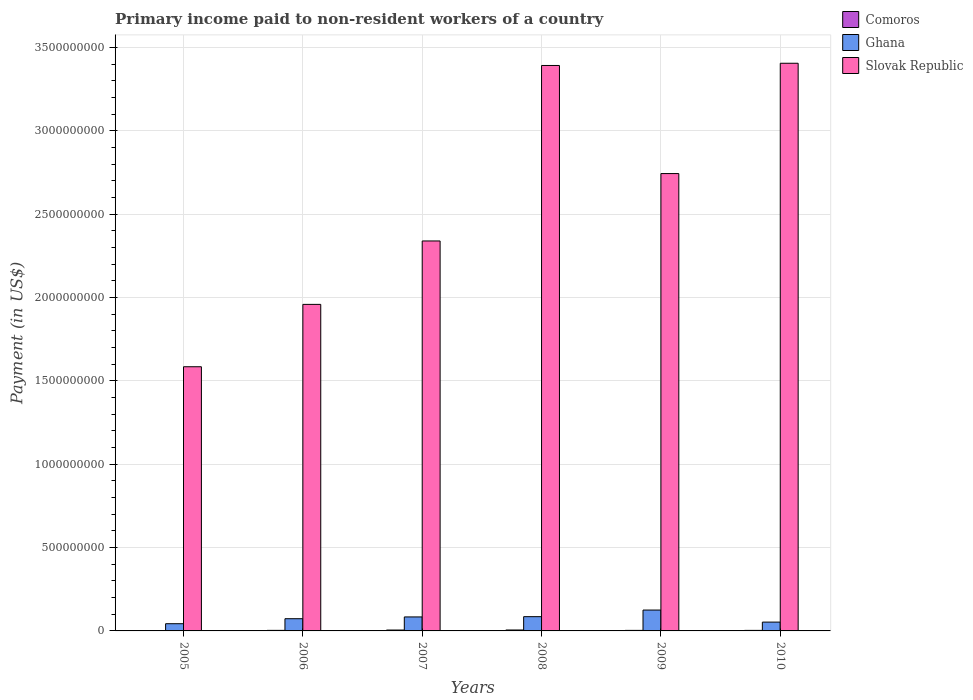How many groups of bars are there?
Offer a terse response. 6. How many bars are there on the 2nd tick from the left?
Keep it short and to the point. 3. In how many cases, is the number of bars for a given year not equal to the number of legend labels?
Provide a succinct answer. 0. What is the amount paid to workers in Slovak Republic in 2008?
Offer a very short reply. 3.39e+09. Across all years, what is the maximum amount paid to workers in Slovak Republic?
Give a very brief answer. 3.41e+09. Across all years, what is the minimum amount paid to workers in Slovak Republic?
Offer a terse response. 1.58e+09. In which year was the amount paid to workers in Ghana maximum?
Your response must be concise. 2009. In which year was the amount paid to workers in Slovak Republic minimum?
Ensure brevity in your answer.  2005. What is the total amount paid to workers in Ghana in the graph?
Keep it short and to the point. 4.64e+08. What is the difference between the amount paid to workers in Ghana in 2005 and that in 2009?
Ensure brevity in your answer.  -8.19e+07. What is the difference between the amount paid to workers in Comoros in 2010 and the amount paid to workers in Ghana in 2006?
Ensure brevity in your answer.  -7.00e+07. What is the average amount paid to workers in Ghana per year?
Ensure brevity in your answer.  7.74e+07. In the year 2009, what is the difference between the amount paid to workers in Slovak Republic and amount paid to workers in Comoros?
Offer a terse response. 2.74e+09. In how many years, is the amount paid to workers in Comoros greater than 1800000000 US$?
Give a very brief answer. 0. What is the ratio of the amount paid to workers in Ghana in 2005 to that in 2008?
Provide a short and direct response. 0.51. Is the amount paid to workers in Slovak Republic in 2005 less than that in 2010?
Make the answer very short. Yes. Is the difference between the amount paid to workers in Slovak Republic in 2008 and 2009 greater than the difference between the amount paid to workers in Comoros in 2008 and 2009?
Your response must be concise. Yes. What is the difference between the highest and the second highest amount paid to workers in Slovak Republic?
Offer a terse response. 1.33e+07. What is the difference between the highest and the lowest amount paid to workers in Slovak Republic?
Give a very brief answer. 1.82e+09. Is the sum of the amount paid to workers in Ghana in 2008 and 2009 greater than the maximum amount paid to workers in Slovak Republic across all years?
Your answer should be very brief. No. What does the 3rd bar from the right in 2005 represents?
Ensure brevity in your answer.  Comoros. Is it the case that in every year, the sum of the amount paid to workers in Comoros and amount paid to workers in Ghana is greater than the amount paid to workers in Slovak Republic?
Your answer should be compact. No. How many bars are there?
Offer a terse response. 18. Does the graph contain any zero values?
Ensure brevity in your answer.  No. Does the graph contain grids?
Your answer should be very brief. Yes. What is the title of the graph?
Ensure brevity in your answer.  Primary income paid to non-resident workers of a country. What is the label or title of the X-axis?
Ensure brevity in your answer.  Years. What is the label or title of the Y-axis?
Your response must be concise. Payment (in US$). What is the Payment (in US$) in Comoros in 2005?
Provide a succinct answer. 2.44e+06. What is the Payment (in US$) of Ghana in 2005?
Provide a short and direct response. 4.33e+07. What is the Payment (in US$) in Slovak Republic in 2005?
Your answer should be very brief. 1.58e+09. What is the Payment (in US$) in Comoros in 2006?
Ensure brevity in your answer.  3.37e+06. What is the Payment (in US$) of Ghana in 2006?
Your response must be concise. 7.33e+07. What is the Payment (in US$) of Slovak Republic in 2006?
Give a very brief answer. 1.96e+09. What is the Payment (in US$) of Comoros in 2007?
Provide a succinct answer. 5.32e+06. What is the Payment (in US$) in Ghana in 2007?
Make the answer very short. 8.40e+07. What is the Payment (in US$) in Slovak Republic in 2007?
Offer a terse response. 2.34e+09. What is the Payment (in US$) in Comoros in 2008?
Ensure brevity in your answer.  5.55e+06. What is the Payment (in US$) of Ghana in 2008?
Give a very brief answer. 8.56e+07. What is the Payment (in US$) in Slovak Republic in 2008?
Give a very brief answer. 3.39e+09. What is the Payment (in US$) in Comoros in 2009?
Your answer should be very brief. 3.19e+06. What is the Payment (in US$) of Ghana in 2009?
Make the answer very short. 1.25e+08. What is the Payment (in US$) in Slovak Republic in 2009?
Ensure brevity in your answer.  2.74e+09. What is the Payment (in US$) in Comoros in 2010?
Provide a succinct answer. 3.23e+06. What is the Payment (in US$) of Ghana in 2010?
Your answer should be compact. 5.29e+07. What is the Payment (in US$) of Slovak Republic in 2010?
Your answer should be very brief. 3.41e+09. Across all years, what is the maximum Payment (in US$) in Comoros?
Your answer should be compact. 5.55e+06. Across all years, what is the maximum Payment (in US$) in Ghana?
Ensure brevity in your answer.  1.25e+08. Across all years, what is the maximum Payment (in US$) of Slovak Republic?
Provide a succinct answer. 3.41e+09. Across all years, what is the minimum Payment (in US$) of Comoros?
Your response must be concise. 2.44e+06. Across all years, what is the minimum Payment (in US$) in Ghana?
Make the answer very short. 4.33e+07. Across all years, what is the minimum Payment (in US$) in Slovak Republic?
Offer a terse response. 1.58e+09. What is the total Payment (in US$) of Comoros in the graph?
Your answer should be compact. 2.31e+07. What is the total Payment (in US$) of Ghana in the graph?
Offer a terse response. 4.64e+08. What is the total Payment (in US$) in Slovak Republic in the graph?
Provide a succinct answer. 1.54e+1. What is the difference between the Payment (in US$) of Comoros in 2005 and that in 2006?
Your answer should be compact. -9.27e+05. What is the difference between the Payment (in US$) in Ghana in 2005 and that in 2006?
Make the answer very short. -3.00e+07. What is the difference between the Payment (in US$) of Slovak Republic in 2005 and that in 2006?
Ensure brevity in your answer.  -3.74e+08. What is the difference between the Payment (in US$) in Comoros in 2005 and that in 2007?
Your answer should be very brief. -2.87e+06. What is the difference between the Payment (in US$) in Ghana in 2005 and that in 2007?
Ensure brevity in your answer.  -4.07e+07. What is the difference between the Payment (in US$) of Slovak Republic in 2005 and that in 2007?
Your answer should be compact. -7.55e+08. What is the difference between the Payment (in US$) in Comoros in 2005 and that in 2008?
Keep it short and to the point. -3.11e+06. What is the difference between the Payment (in US$) of Ghana in 2005 and that in 2008?
Provide a succinct answer. -4.23e+07. What is the difference between the Payment (in US$) of Slovak Republic in 2005 and that in 2008?
Offer a very short reply. -1.81e+09. What is the difference between the Payment (in US$) in Comoros in 2005 and that in 2009?
Keep it short and to the point. -7.48e+05. What is the difference between the Payment (in US$) of Ghana in 2005 and that in 2009?
Make the answer very short. -8.19e+07. What is the difference between the Payment (in US$) of Slovak Republic in 2005 and that in 2009?
Offer a very short reply. -1.16e+09. What is the difference between the Payment (in US$) in Comoros in 2005 and that in 2010?
Provide a short and direct response. -7.91e+05. What is the difference between the Payment (in US$) in Ghana in 2005 and that in 2010?
Offer a very short reply. -9.65e+06. What is the difference between the Payment (in US$) in Slovak Republic in 2005 and that in 2010?
Ensure brevity in your answer.  -1.82e+09. What is the difference between the Payment (in US$) of Comoros in 2006 and that in 2007?
Keep it short and to the point. -1.95e+06. What is the difference between the Payment (in US$) in Ghana in 2006 and that in 2007?
Ensure brevity in your answer.  -1.07e+07. What is the difference between the Payment (in US$) of Slovak Republic in 2006 and that in 2007?
Offer a terse response. -3.81e+08. What is the difference between the Payment (in US$) in Comoros in 2006 and that in 2008?
Give a very brief answer. -2.18e+06. What is the difference between the Payment (in US$) in Ghana in 2006 and that in 2008?
Give a very brief answer. -1.23e+07. What is the difference between the Payment (in US$) of Slovak Republic in 2006 and that in 2008?
Keep it short and to the point. -1.43e+09. What is the difference between the Payment (in US$) of Comoros in 2006 and that in 2009?
Provide a short and direct response. 1.78e+05. What is the difference between the Payment (in US$) in Ghana in 2006 and that in 2009?
Keep it short and to the point. -5.19e+07. What is the difference between the Payment (in US$) of Slovak Republic in 2006 and that in 2009?
Keep it short and to the point. -7.85e+08. What is the difference between the Payment (in US$) in Comoros in 2006 and that in 2010?
Offer a terse response. 1.35e+05. What is the difference between the Payment (in US$) of Ghana in 2006 and that in 2010?
Offer a very short reply. 2.03e+07. What is the difference between the Payment (in US$) of Slovak Republic in 2006 and that in 2010?
Provide a succinct answer. -1.45e+09. What is the difference between the Payment (in US$) in Comoros in 2007 and that in 2008?
Offer a terse response. -2.30e+05. What is the difference between the Payment (in US$) in Ghana in 2007 and that in 2008?
Your response must be concise. -1.58e+06. What is the difference between the Payment (in US$) in Slovak Republic in 2007 and that in 2008?
Keep it short and to the point. -1.05e+09. What is the difference between the Payment (in US$) in Comoros in 2007 and that in 2009?
Offer a very short reply. 2.13e+06. What is the difference between the Payment (in US$) in Ghana in 2007 and that in 2009?
Ensure brevity in your answer.  -4.12e+07. What is the difference between the Payment (in US$) in Slovak Republic in 2007 and that in 2009?
Keep it short and to the point. -4.04e+08. What is the difference between the Payment (in US$) of Comoros in 2007 and that in 2010?
Offer a very short reply. 2.08e+06. What is the difference between the Payment (in US$) in Ghana in 2007 and that in 2010?
Provide a succinct answer. 3.11e+07. What is the difference between the Payment (in US$) in Slovak Republic in 2007 and that in 2010?
Your response must be concise. -1.07e+09. What is the difference between the Payment (in US$) in Comoros in 2008 and that in 2009?
Keep it short and to the point. 2.36e+06. What is the difference between the Payment (in US$) in Ghana in 2008 and that in 2009?
Offer a very short reply. -3.96e+07. What is the difference between the Payment (in US$) of Slovak Republic in 2008 and that in 2009?
Your response must be concise. 6.49e+08. What is the difference between the Payment (in US$) in Comoros in 2008 and that in 2010?
Your response must be concise. 2.31e+06. What is the difference between the Payment (in US$) in Ghana in 2008 and that in 2010?
Give a very brief answer. 3.26e+07. What is the difference between the Payment (in US$) of Slovak Republic in 2008 and that in 2010?
Provide a succinct answer. -1.33e+07. What is the difference between the Payment (in US$) of Comoros in 2009 and that in 2010?
Offer a terse response. -4.30e+04. What is the difference between the Payment (in US$) in Ghana in 2009 and that in 2010?
Provide a short and direct response. 7.23e+07. What is the difference between the Payment (in US$) of Slovak Republic in 2009 and that in 2010?
Offer a terse response. -6.62e+08. What is the difference between the Payment (in US$) in Comoros in 2005 and the Payment (in US$) in Ghana in 2006?
Your answer should be compact. -7.08e+07. What is the difference between the Payment (in US$) in Comoros in 2005 and the Payment (in US$) in Slovak Republic in 2006?
Give a very brief answer. -1.96e+09. What is the difference between the Payment (in US$) in Ghana in 2005 and the Payment (in US$) in Slovak Republic in 2006?
Make the answer very short. -1.92e+09. What is the difference between the Payment (in US$) in Comoros in 2005 and the Payment (in US$) in Ghana in 2007?
Give a very brief answer. -8.15e+07. What is the difference between the Payment (in US$) in Comoros in 2005 and the Payment (in US$) in Slovak Republic in 2007?
Ensure brevity in your answer.  -2.34e+09. What is the difference between the Payment (in US$) in Ghana in 2005 and the Payment (in US$) in Slovak Republic in 2007?
Your answer should be very brief. -2.30e+09. What is the difference between the Payment (in US$) in Comoros in 2005 and the Payment (in US$) in Ghana in 2008?
Your response must be concise. -8.31e+07. What is the difference between the Payment (in US$) of Comoros in 2005 and the Payment (in US$) of Slovak Republic in 2008?
Give a very brief answer. -3.39e+09. What is the difference between the Payment (in US$) of Ghana in 2005 and the Payment (in US$) of Slovak Republic in 2008?
Provide a succinct answer. -3.35e+09. What is the difference between the Payment (in US$) in Comoros in 2005 and the Payment (in US$) in Ghana in 2009?
Make the answer very short. -1.23e+08. What is the difference between the Payment (in US$) of Comoros in 2005 and the Payment (in US$) of Slovak Republic in 2009?
Make the answer very short. -2.74e+09. What is the difference between the Payment (in US$) of Ghana in 2005 and the Payment (in US$) of Slovak Republic in 2009?
Make the answer very short. -2.70e+09. What is the difference between the Payment (in US$) in Comoros in 2005 and the Payment (in US$) in Ghana in 2010?
Your response must be concise. -5.05e+07. What is the difference between the Payment (in US$) in Comoros in 2005 and the Payment (in US$) in Slovak Republic in 2010?
Make the answer very short. -3.40e+09. What is the difference between the Payment (in US$) of Ghana in 2005 and the Payment (in US$) of Slovak Republic in 2010?
Make the answer very short. -3.36e+09. What is the difference between the Payment (in US$) in Comoros in 2006 and the Payment (in US$) in Ghana in 2007?
Give a very brief answer. -8.06e+07. What is the difference between the Payment (in US$) of Comoros in 2006 and the Payment (in US$) of Slovak Republic in 2007?
Offer a terse response. -2.34e+09. What is the difference between the Payment (in US$) of Ghana in 2006 and the Payment (in US$) of Slovak Republic in 2007?
Your answer should be compact. -2.27e+09. What is the difference between the Payment (in US$) of Comoros in 2006 and the Payment (in US$) of Ghana in 2008?
Offer a terse response. -8.22e+07. What is the difference between the Payment (in US$) in Comoros in 2006 and the Payment (in US$) in Slovak Republic in 2008?
Offer a very short reply. -3.39e+09. What is the difference between the Payment (in US$) of Ghana in 2006 and the Payment (in US$) of Slovak Republic in 2008?
Offer a terse response. -3.32e+09. What is the difference between the Payment (in US$) of Comoros in 2006 and the Payment (in US$) of Ghana in 2009?
Provide a succinct answer. -1.22e+08. What is the difference between the Payment (in US$) in Comoros in 2006 and the Payment (in US$) in Slovak Republic in 2009?
Provide a succinct answer. -2.74e+09. What is the difference between the Payment (in US$) in Ghana in 2006 and the Payment (in US$) in Slovak Republic in 2009?
Your response must be concise. -2.67e+09. What is the difference between the Payment (in US$) in Comoros in 2006 and the Payment (in US$) in Ghana in 2010?
Your answer should be compact. -4.96e+07. What is the difference between the Payment (in US$) of Comoros in 2006 and the Payment (in US$) of Slovak Republic in 2010?
Give a very brief answer. -3.40e+09. What is the difference between the Payment (in US$) of Ghana in 2006 and the Payment (in US$) of Slovak Republic in 2010?
Your answer should be compact. -3.33e+09. What is the difference between the Payment (in US$) in Comoros in 2007 and the Payment (in US$) in Ghana in 2008?
Your response must be concise. -8.02e+07. What is the difference between the Payment (in US$) in Comoros in 2007 and the Payment (in US$) in Slovak Republic in 2008?
Make the answer very short. -3.39e+09. What is the difference between the Payment (in US$) of Ghana in 2007 and the Payment (in US$) of Slovak Republic in 2008?
Make the answer very short. -3.31e+09. What is the difference between the Payment (in US$) of Comoros in 2007 and the Payment (in US$) of Ghana in 2009?
Provide a succinct answer. -1.20e+08. What is the difference between the Payment (in US$) of Comoros in 2007 and the Payment (in US$) of Slovak Republic in 2009?
Your answer should be very brief. -2.74e+09. What is the difference between the Payment (in US$) in Ghana in 2007 and the Payment (in US$) in Slovak Republic in 2009?
Provide a short and direct response. -2.66e+09. What is the difference between the Payment (in US$) of Comoros in 2007 and the Payment (in US$) of Ghana in 2010?
Your answer should be very brief. -4.76e+07. What is the difference between the Payment (in US$) of Comoros in 2007 and the Payment (in US$) of Slovak Republic in 2010?
Provide a short and direct response. -3.40e+09. What is the difference between the Payment (in US$) of Ghana in 2007 and the Payment (in US$) of Slovak Republic in 2010?
Your answer should be very brief. -3.32e+09. What is the difference between the Payment (in US$) of Comoros in 2008 and the Payment (in US$) of Ghana in 2009?
Give a very brief answer. -1.20e+08. What is the difference between the Payment (in US$) in Comoros in 2008 and the Payment (in US$) in Slovak Republic in 2009?
Your answer should be very brief. -2.74e+09. What is the difference between the Payment (in US$) of Ghana in 2008 and the Payment (in US$) of Slovak Republic in 2009?
Your answer should be very brief. -2.66e+09. What is the difference between the Payment (in US$) in Comoros in 2008 and the Payment (in US$) in Ghana in 2010?
Ensure brevity in your answer.  -4.74e+07. What is the difference between the Payment (in US$) of Comoros in 2008 and the Payment (in US$) of Slovak Republic in 2010?
Offer a very short reply. -3.40e+09. What is the difference between the Payment (in US$) of Ghana in 2008 and the Payment (in US$) of Slovak Republic in 2010?
Provide a succinct answer. -3.32e+09. What is the difference between the Payment (in US$) in Comoros in 2009 and the Payment (in US$) in Ghana in 2010?
Your response must be concise. -4.97e+07. What is the difference between the Payment (in US$) of Comoros in 2009 and the Payment (in US$) of Slovak Republic in 2010?
Provide a short and direct response. -3.40e+09. What is the difference between the Payment (in US$) of Ghana in 2009 and the Payment (in US$) of Slovak Republic in 2010?
Give a very brief answer. -3.28e+09. What is the average Payment (in US$) of Comoros per year?
Provide a succinct answer. 3.85e+06. What is the average Payment (in US$) of Ghana per year?
Offer a terse response. 7.74e+07. What is the average Payment (in US$) in Slovak Republic per year?
Your answer should be very brief. 2.57e+09. In the year 2005, what is the difference between the Payment (in US$) of Comoros and Payment (in US$) of Ghana?
Give a very brief answer. -4.08e+07. In the year 2005, what is the difference between the Payment (in US$) in Comoros and Payment (in US$) in Slovak Republic?
Provide a succinct answer. -1.58e+09. In the year 2005, what is the difference between the Payment (in US$) in Ghana and Payment (in US$) in Slovak Republic?
Your answer should be very brief. -1.54e+09. In the year 2006, what is the difference between the Payment (in US$) in Comoros and Payment (in US$) in Ghana?
Ensure brevity in your answer.  -6.99e+07. In the year 2006, what is the difference between the Payment (in US$) in Comoros and Payment (in US$) in Slovak Republic?
Your response must be concise. -1.96e+09. In the year 2006, what is the difference between the Payment (in US$) of Ghana and Payment (in US$) of Slovak Republic?
Provide a succinct answer. -1.89e+09. In the year 2007, what is the difference between the Payment (in US$) of Comoros and Payment (in US$) of Ghana?
Your response must be concise. -7.87e+07. In the year 2007, what is the difference between the Payment (in US$) of Comoros and Payment (in US$) of Slovak Republic?
Give a very brief answer. -2.33e+09. In the year 2007, what is the difference between the Payment (in US$) of Ghana and Payment (in US$) of Slovak Republic?
Give a very brief answer. -2.26e+09. In the year 2008, what is the difference between the Payment (in US$) in Comoros and Payment (in US$) in Ghana?
Keep it short and to the point. -8.00e+07. In the year 2008, what is the difference between the Payment (in US$) of Comoros and Payment (in US$) of Slovak Republic?
Your answer should be compact. -3.39e+09. In the year 2008, what is the difference between the Payment (in US$) in Ghana and Payment (in US$) in Slovak Republic?
Make the answer very short. -3.31e+09. In the year 2009, what is the difference between the Payment (in US$) in Comoros and Payment (in US$) in Ghana?
Provide a short and direct response. -1.22e+08. In the year 2009, what is the difference between the Payment (in US$) of Comoros and Payment (in US$) of Slovak Republic?
Your response must be concise. -2.74e+09. In the year 2009, what is the difference between the Payment (in US$) of Ghana and Payment (in US$) of Slovak Republic?
Your answer should be very brief. -2.62e+09. In the year 2010, what is the difference between the Payment (in US$) in Comoros and Payment (in US$) in Ghana?
Your answer should be compact. -4.97e+07. In the year 2010, what is the difference between the Payment (in US$) in Comoros and Payment (in US$) in Slovak Republic?
Offer a terse response. -3.40e+09. In the year 2010, what is the difference between the Payment (in US$) of Ghana and Payment (in US$) of Slovak Republic?
Keep it short and to the point. -3.35e+09. What is the ratio of the Payment (in US$) in Comoros in 2005 to that in 2006?
Offer a terse response. 0.72. What is the ratio of the Payment (in US$) of Ghana in 2005 to that in 2006?
Your response must be concise. 0.59. What is the ratio of the Payment (in US$) in Slovak Republic in 2005 to that in 2006?
Provide a short and direct response. 0.81. What is the ratio of the Payment (in US$) in Comoros in 2005 to that in 2007?
Ensure brevity in your answer.  0.46. What is the ratio of the Payment (in US$) in Ghana in 2005 to that in 2007?
Provide a short and direct response. 0.52. What is the ratio of the Payment (in US$) of Slovak Republic in 2005 to that in 2007?
Ensure brevity in your answer.  0.68. What is the ratio of the Payment (in US$) of Comoros in 2005 to that in 2008?
Make the answer very short. 0.44. What is the ratio of the Payment (in US$) in Ghana in 2005 to that in 2008?
Your answer should be compact. 0.51. What is the ratio of the Payment (in US$) of Slovak Republic in 2005 to that in 2008?
Provide a short and direct response. 0.47. What is the ratio of the Payment (in US$) of Comoros in 2005 to that in 2009?
Provide a succinct answer. 0.77. What is the ratio of the Payment (in US$) in Ghana in 2005 to that in 2009?
Provide a succinct answer. 0.35. What is the ratio of the Payment (in US$) of Slovak Republic in 2005 to that in 2009?
Your answer should be compact. 0.58. What is the ratio of the Payment (in US$) of Comoros in 2005 to that in 2010?
Your response must be concise. 0.76. What is the ratio of the Payment (in US$) in Ghana in 2005 to that in 2010?
Your answer should be compact. 0.82. What is the ratio of the Payment (in US$) of Slovak Republic in 2005 to that in 2010?
Give a very brief answer. 0.47. What is the ratio of the Payment (in US$) of Comoros in 2006 to that in 2007?
Offer a very short reply. 0.63. What is the ratio of the Payment (in US$) in Ghana in 2006 to that in 2007?
Ensure brevity in your answer.  0.87. What is the ratio of the Payment (in US$) in Slovak Republic in 2006 to that in 2007?
Your answer should be compact. 0.84. What is the ratio of the Payment (in US$) of Comoros in 2006 to that in 2008?
Your answer should be compact. 0.61. What is the ratio of the Payment (in US$) of Ghana in 2006 to that in 2008?
Provide a succinct answer. 0.86. What is the ratio of the Payment (in US$) in Slovak Republic in 2006 to that in 2008?
Make the answer very short. 0.58. What is the ratio of the Payment (in US$) in Comoros in 2006 to that in 2009?
Give a very brief answer. 1.06. What is the ratio of the Payment (in US$) in Ghana in 2006 to that in 2009?
Keep it short and to the point. 0.59. What is the ratio of the Payment (in US$) of Slovak Republic in 2006 to that in 2009?
Your response must be concise. 0.71. What is the ratio of the Payment (in US$) of Comoros in 2006 to that in 2010?
Make the answer very short. 1.04. What is the ratio of the Payment (in US$) of Ghana in 2006 to that in 2010?
Ensure brevity in your answer.  1.38. What is the ratio of the Payment (in US$) in Slovak Republic in 2006 to that in 2010?
Your answer should be very brief. 0.58. What is the ratio of the Payment (in US$) in Comoros in 2007 to that in 2008?
Your answer should be very brief. 0.96. What is the ratio of the Payment (in US$) of Ghana in 2007 to that in 2008?
Provide a short and direct response. 0.98. What is the ratio of the Payment (in US$) of Slovak Republic in 2007 to that in 2008?
Give a very brief answer. 0.69. What is the ratio of the Payment (in US$) in Comoros in 2007 to that in 2009?
Provide a short and direct response. 1.67. What is the ratio of the Payment (in US$) of Ghana in 2007 to that in 2009?
Give a very brief answer. 0.67. What is the ratio of the Payment (in US$) of Slovak Republic in 2007 to that in 2009?
Provide a short and direct response. 0.85. What is the ratio of the Payment (in US$) in Comoros in 2007 to that in 2010?
Offer a terse response. 1.64. What is the ratio of the Payment (in US$) of Ghana in 2007 to that in 2010?
Provide a short and direct response. 1.59. What is the ratio of the Payment (in US$) in Slovak Republic in 2007 to that in 2010?
Your response must be concise. 0.69. What is the ratio of the Payment (in US$) in Comoros in 2008 to that in 2009?
Your response must be concise. 1.74. What is the ratio of the Payment (in US$) in Ghana in 2008 to that in 2009?
Give a very brief answer. 0.68. What is the ratio of the Payment (in US$) in Slovak Republic in 2008 to that in 2009?
Ensure brevity in your answer.  1.24. What is the ratio of the Payment (in US$) of Comoros in 2008 to that in 2010?
Provide a short and direct response. 1.72. What is the ratio of the Payment (in US$) of Ghana in 2008 to that in 2010?
Keep it short and to the point. 1.62. What is the ratio of the Payment (in US$) in Slovak Republic in 2008 to that in 2010?
Your answer should be compact. 1. What is the ratio of the Payment (in US$) in Comoros in 2009 to that in 2010?
Offer a terse response. 0.99. What is the ratio of the Payment (in US$) of Ghana in 2009 to that in 2010?
Your answer should be very brief. 2.37. What is the ratio of the Payment (in US$) of Slovak Republic in 2009 to that in 2010?
Offer a terse response. 0.81. What is the difference between the highest and the second highest Payment (in US$) in Comoros?
Give a very brief answer. 2.30e+05. What is the difference between the highest and the second highest Payment (in US$) in Ghana?
Offer a very short reply. 3.96e+07. What is the difference between the highest and the second highest Payment (in US$) in Slovak Republic?
Offer a terse response. 1.33e+07. What is the difference between the highest and the lowest Payment (in US$) in Comoros?
Make the answer very short. 3.11e+06. What is the difference between the highest and the lowest Payment (in US$) of Ghana?
Provide a short and direct response. 8.19e+07. What is the difference between the highest and the lowest Payment (in US$) of Slovak Republic?
Offer a terse response. 1.82e+09. 